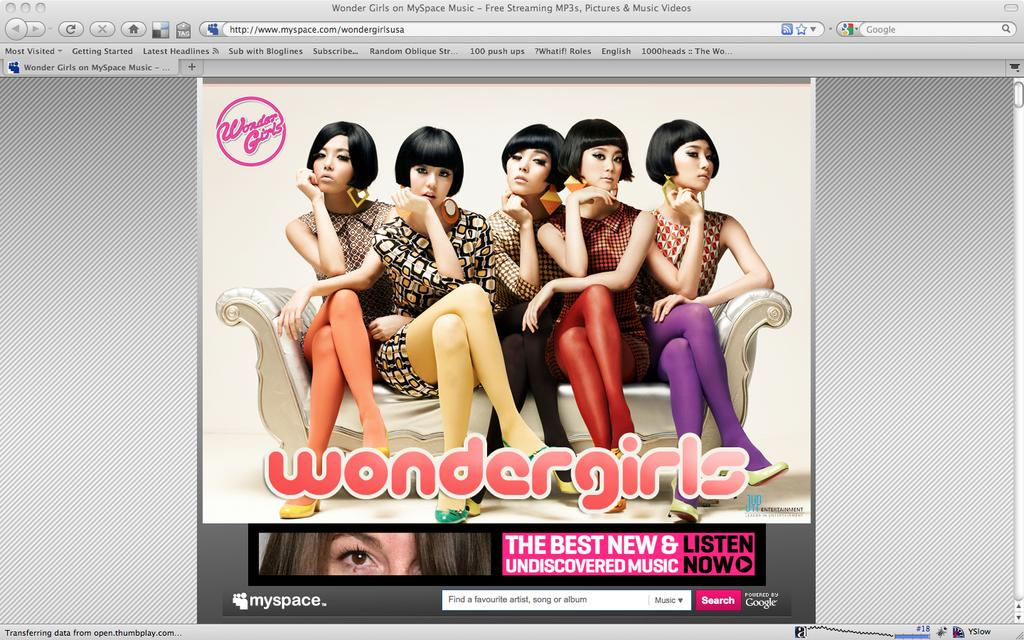What type of content is displayed in the image? The image is of a web page. What can be seen in the image besides the web page layout? There is an image of people sitting on a couch. What other information is present on the web page? There is text on the web page. How many chickens are sitting on the couch in the image? There are no chickens present in the image; it features an image of people sitting on a couch. What type of crow can be seen flying over the web page in the image? There is no crow present in the image; it is a web page displayed on a screen or device. 